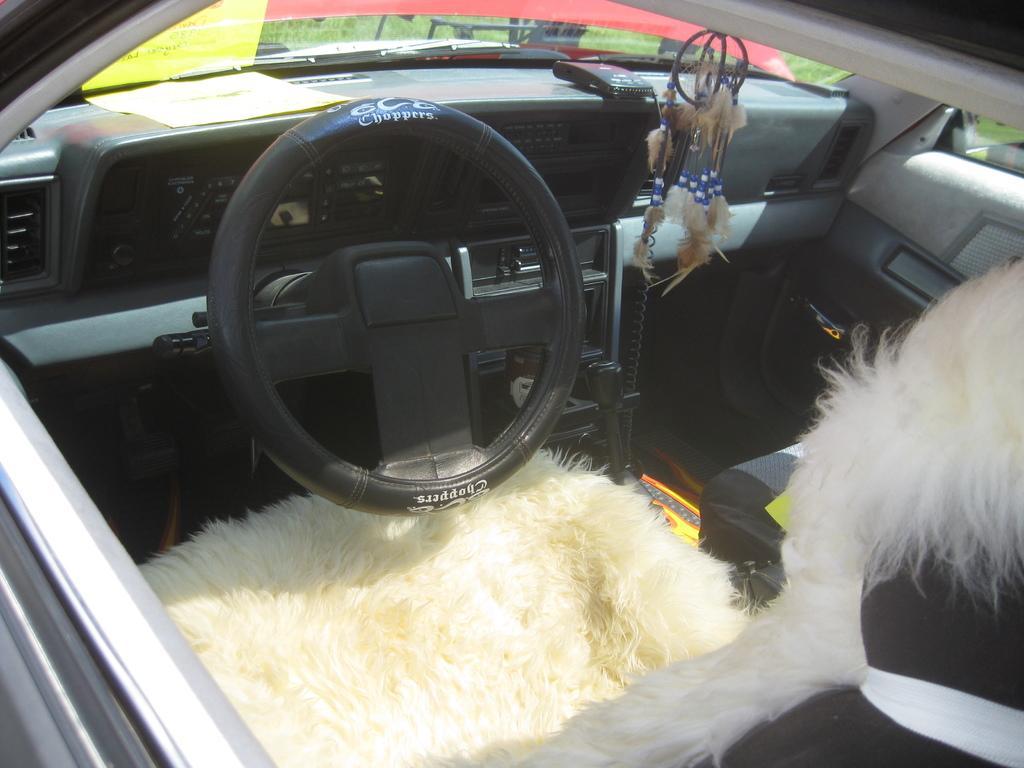How would you summarize this image in a sentence or two? In this image, I can see the inside view of a car with a steering wheel, hand gear, seats, auto gauge, dashboard and doors. 